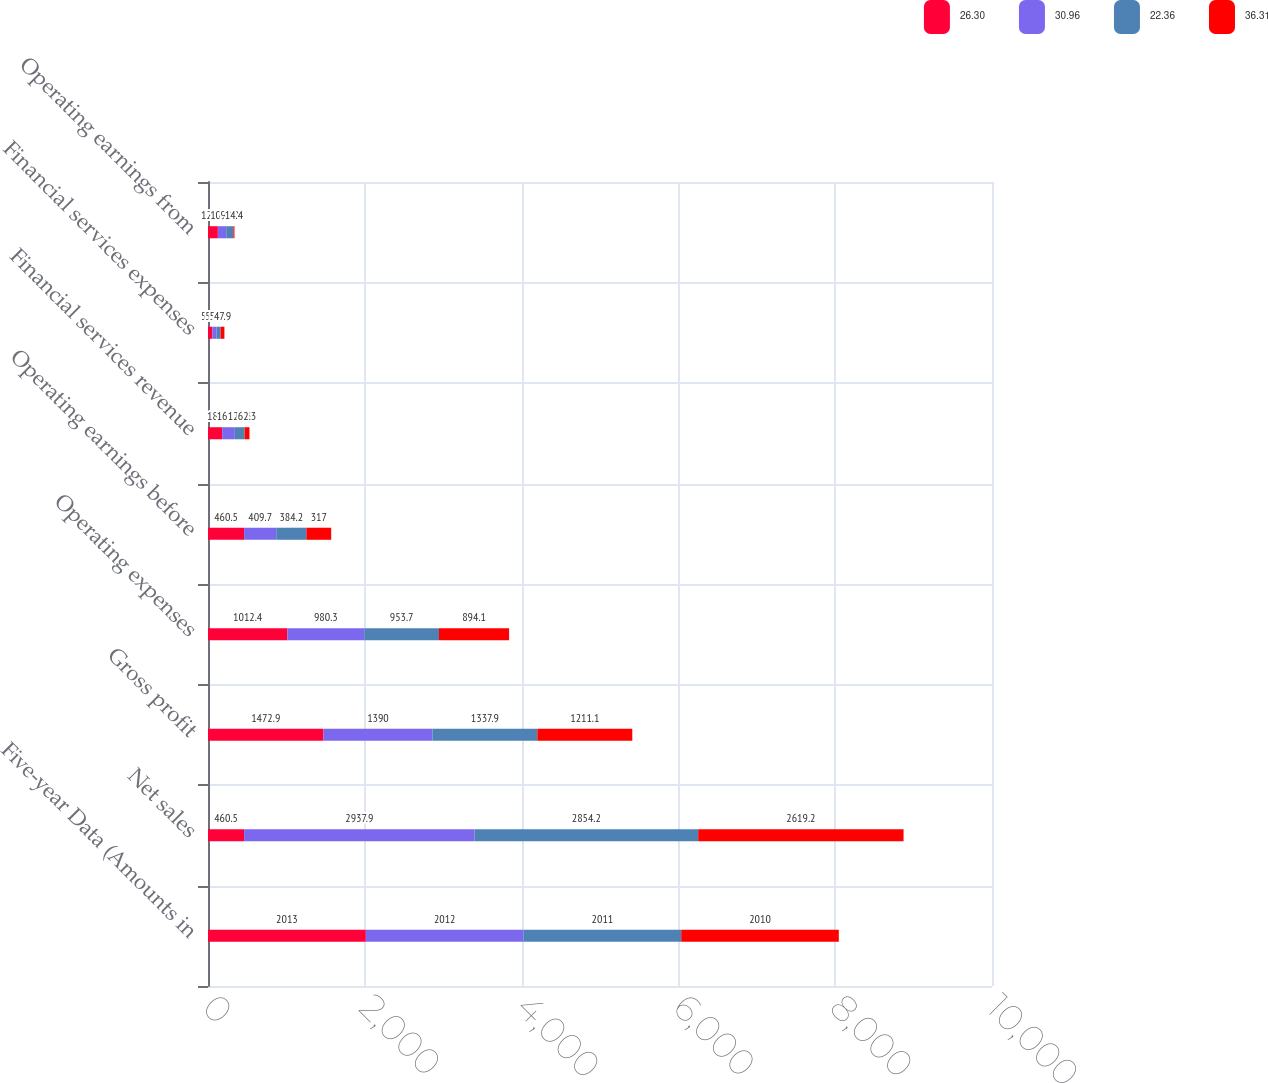Convert chart. <chart><loc_0><loc_0><loc_500><loc_500><stacked_bar_chart><ecel><fcel>Five-year Data (Amounts in<fcel>Net sales<fcel>Gross profit<fcel>Operating expenses<fcel>Operating earnings before<fcel>Financial services revenue<fcel>Financial services expenses<fcel>Operating earnings from<nl><fcel>26.3<fcel>2013<fcel>460.5<fcel>1472.9<fcel>1012.4<fcel>460.5<fcel>181<fcel>55.3<fcel>125.7<nl><fcel>30.96<fcel>2012<fcel>2937.9<fcel>1390<fcel>980.3<fcel>409.7<fcel>161.3<fcel>54.6<fcel>106.7<nl><fcel>22.36<fcel>2011<fcel>2854.2<fcel>1337.9<fcel>953.7<fcel>384.2<fcel>124.3<fcel>51.4<fcel>90.9<nl><fcel>36.31<fcel>2010<fcel>2619.2<fcel>1211.1<fcel>894.1<fcel>317<fcel>62.3<fcel>47.9<fcel>14.4<nl></chart> 